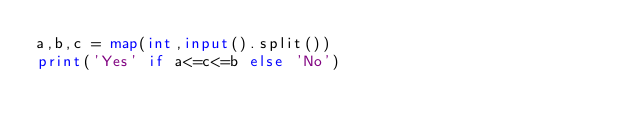<code> <loc_0><loc_0><loc_500><loc_500><_Python_>a,b,c = map(int,input().split())
print('Yes' if a<=c<=b else 'No')</code> 